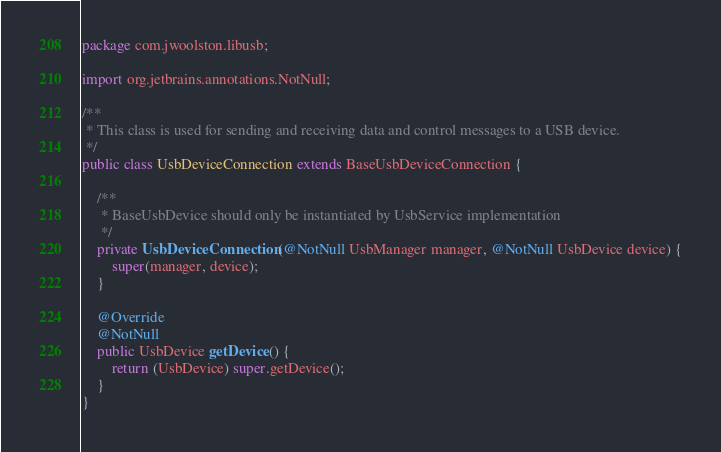Convert code to text. <code><loc_0><loc_0><loc_500><loc_500><_Java_>package com.jwoolston.libusb;

import org.jetbrains.annotations.NotNull;

/**
 * This class is used for sending and receiving data and control messages to a USB device.
 */
public class UsbDeviceConnection extends BaseUsbDeviceConnection {

    /**
     * BaseUsbDevice should only be instantiated by UsbService implementation
     */
    private UsbDeviceConnection(@NotNull UsbManager manager, @NotNull UsbDevice device) {
        super(manager, device);
    }

    @Override
    @NotNull
    public UsbDevice getDevice() {
        return (UsbDevice) super.getDevice();
    }
}
</code> 